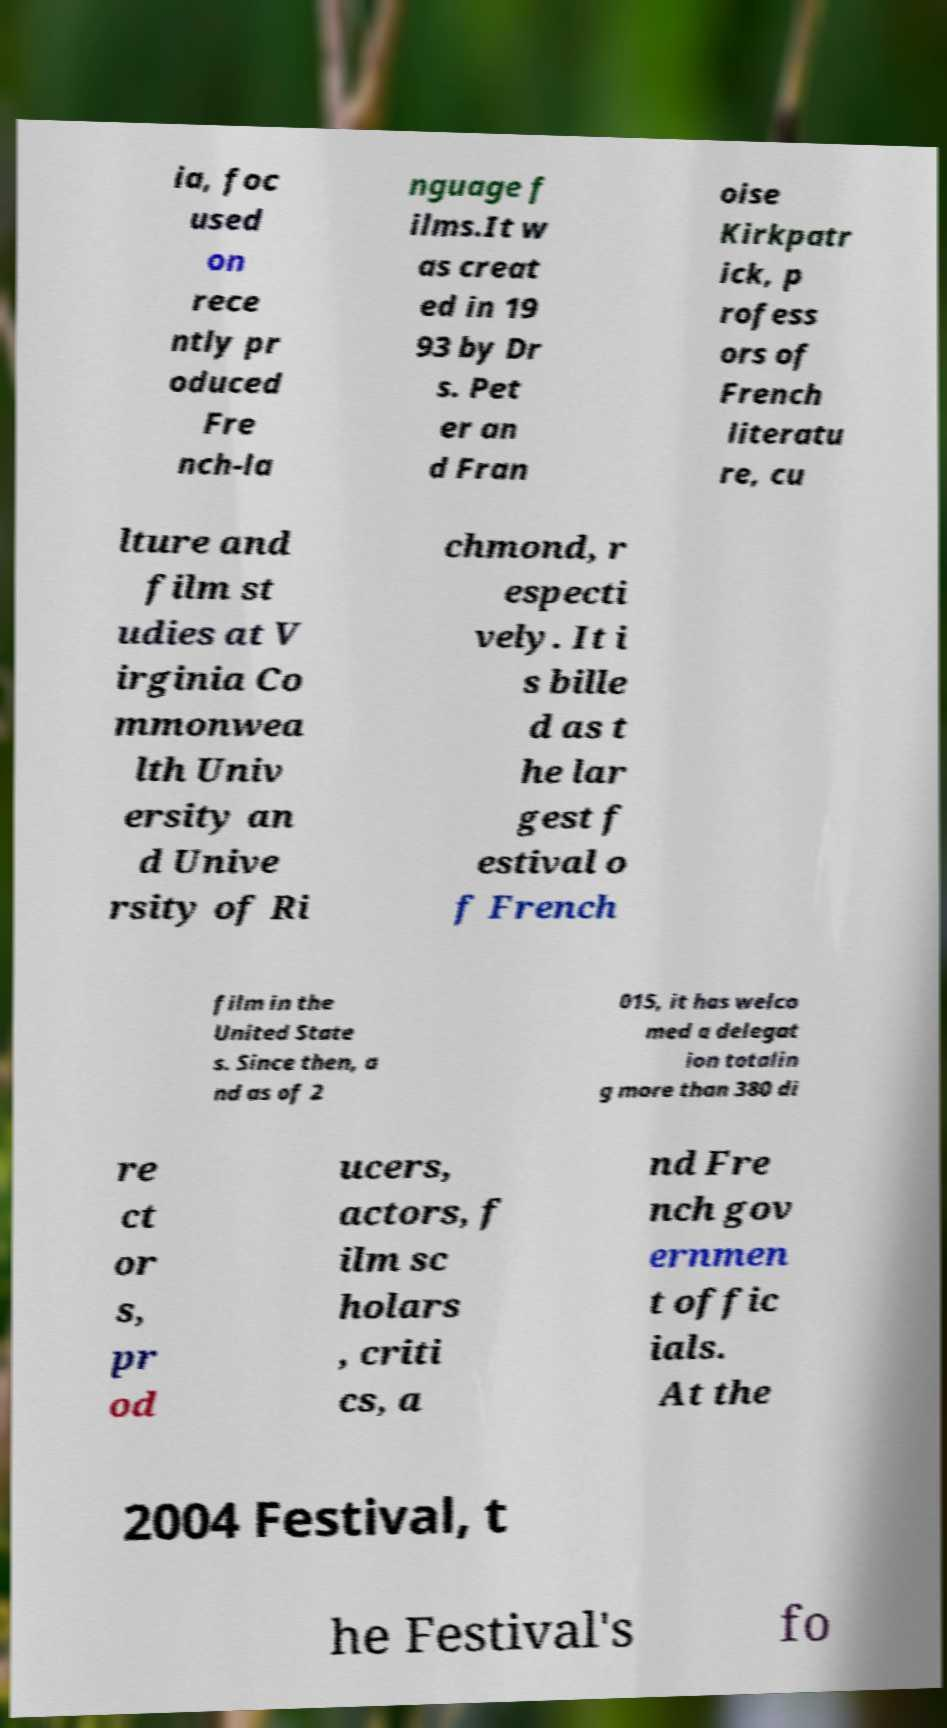Please identify and transcribe the text found in this image. ia, foc used on rece ntly pr oduced Fre nch-la nguage f ilms.It w as creat ed in 19 93 by Dr s. Pet er an d Fran oise Kirkpatr ick, p rofess ors of French literatu re, cu lture and film st udies at V irginia Co mmonwea lth Univ ersity an d Unive rsity of Ri chmond, r especti vely. It i s bille d as t he lar gest f estival o f French film in the United State s. Since then, a nd as of 2 015, it has welco med a delegat ion totalin g more than 380 di re ct or s, pr od ucers, actors, f ilm sc holars , criti cs, a nd Fre nch gov ernmen t offic ials. At the 2004 Festival, t he Festival's fo 